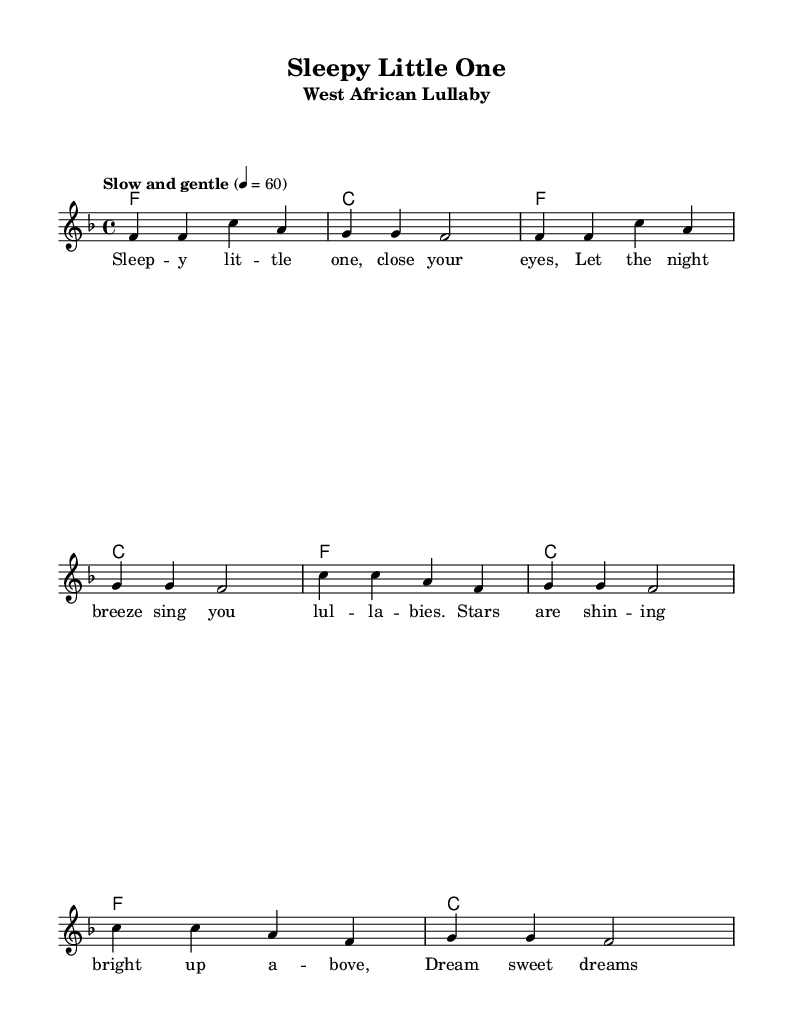What is the key signature of this music? The key signature is indicated by the number of sharps or flats at the beginning of the staff. In this sheet music, there is a single flat, which indicates the key of F major.
Answer: F major What is the time signature of this music? The time signature is found at the beginning of the staff, showing how many beats are in each measure. Here, the time signature is 4/4, meaning there are four beats in each measure.
Answer: 4/4 What is the tempo marking of this piece? The tempo marking is usually displayed above the staff as an indication of the speed of the music. In this case, it says "Slow and gentle," suggesting a calm and relaxed pace.
Answer: Slow and gentle How many measures are in the melody section? To determine the number of measures, we can count the vertical lines (bar lines) in the melody part. There are eight measures counted from the beginning to the end of the melody section.
Answer: Eight What words are used in the first line of the lyrics? The first line of lyrics is present below the melody and starts with the words "Sleepy little one, close your eyes." This gives an idea of the soothing nature of the lullaby.
Answer: Sleepy little one, close your eyes What type of music is this piece classified as? This music falls under the category of lullabies and nursery rhymes, which are typically short, simple songs aimed at soothing young children. In this case, it is specifically a West African lullaby.
Answer: West African lullaby 